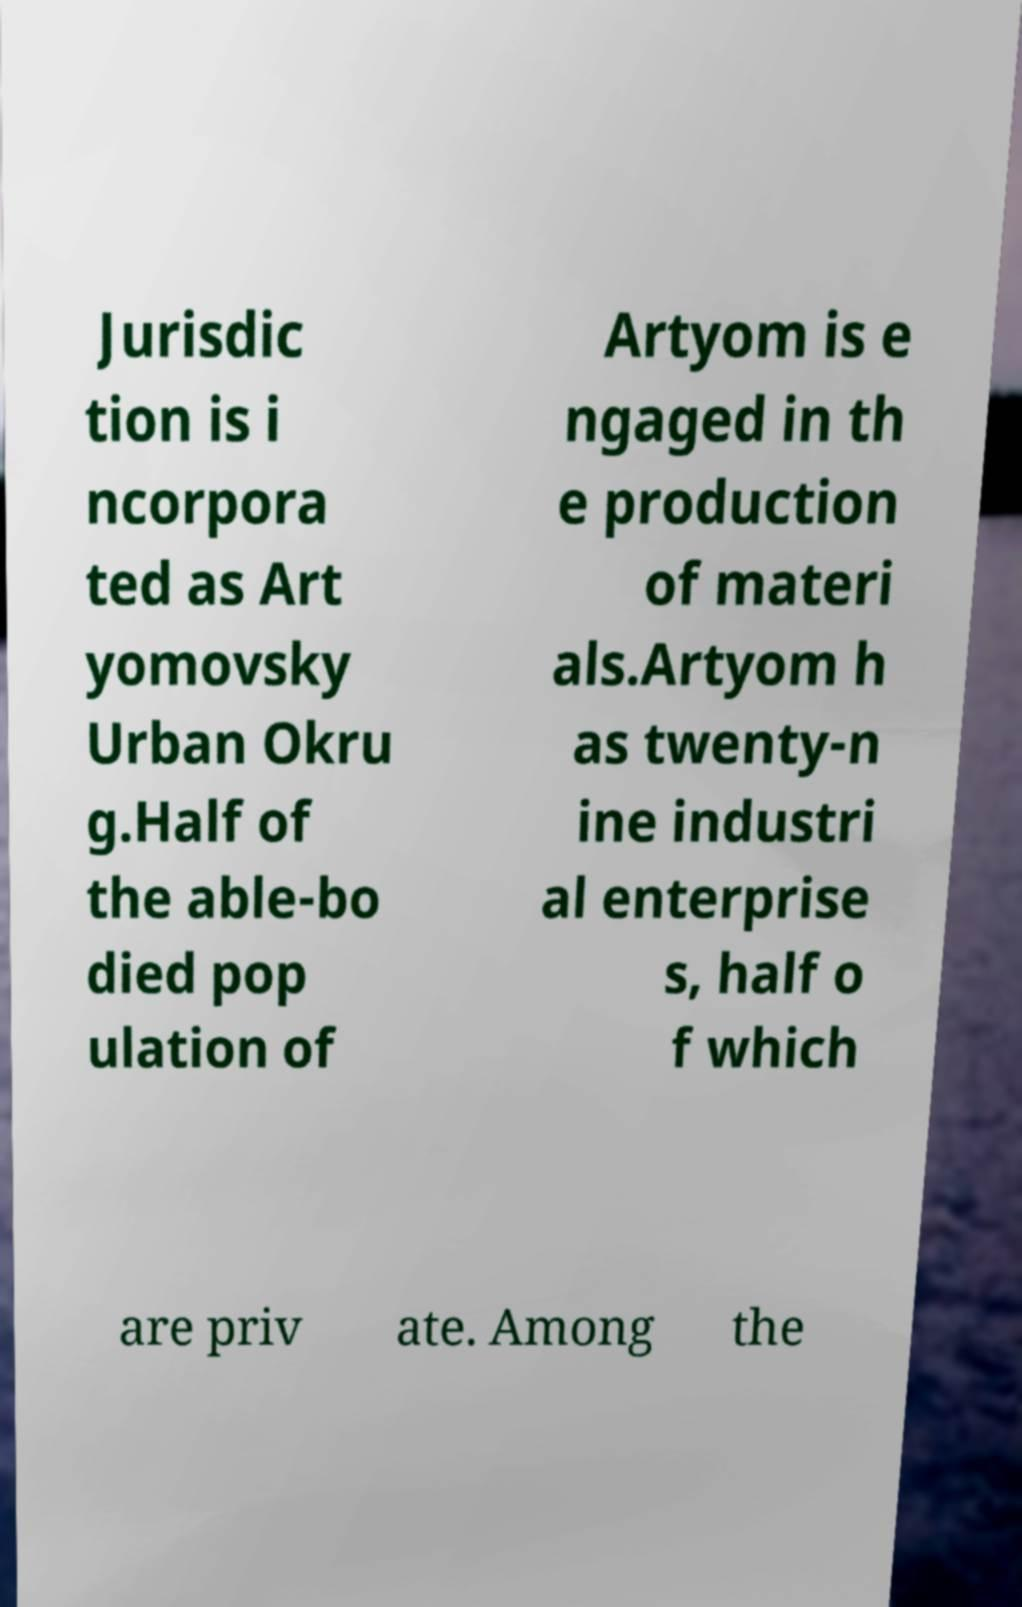Can you read and provide the text displayed in the image?This photo seems to have some interesting text. Can you extract and type it out for me? Jurisdic tion is i ncorpora ted as Art yomovsky Urban Okru g.Half of the able-bo died pop ulation of Artyom is e ngaged in th e production of materi als.Artyom h as twenty-n ine industri al enterprise s, half o f which are priv ate. Among the 